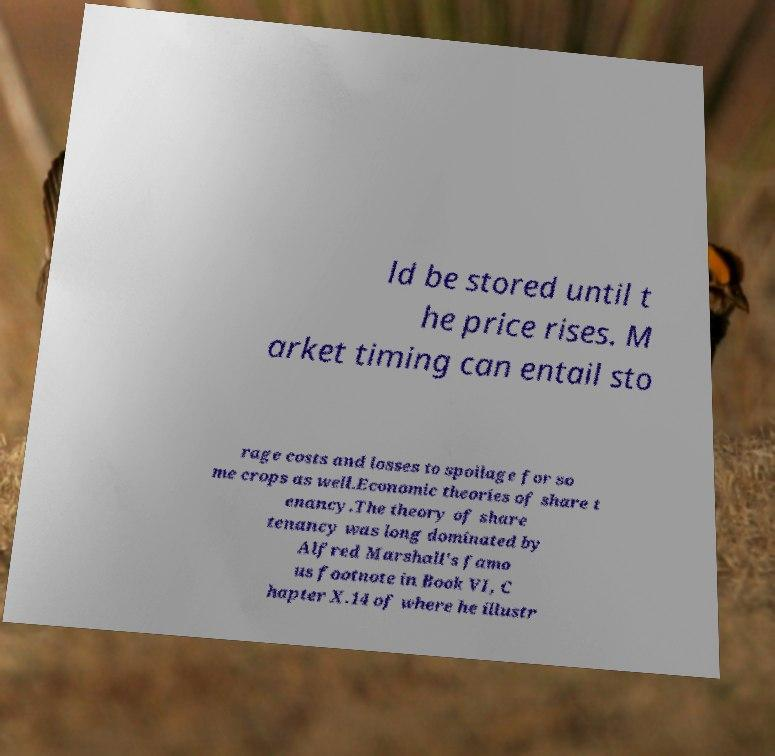Could you extract and type out the text from this image? ld be stored until t he price rises. M arket timing can entail sto rage costs and losses to spoilage for so me crops as well.Economic theories of share t enancy.The theory of share tenancy was long dominated by Alfred Marshall's famo us footnote in Book VI, C hapter X.14 of where he illustr 